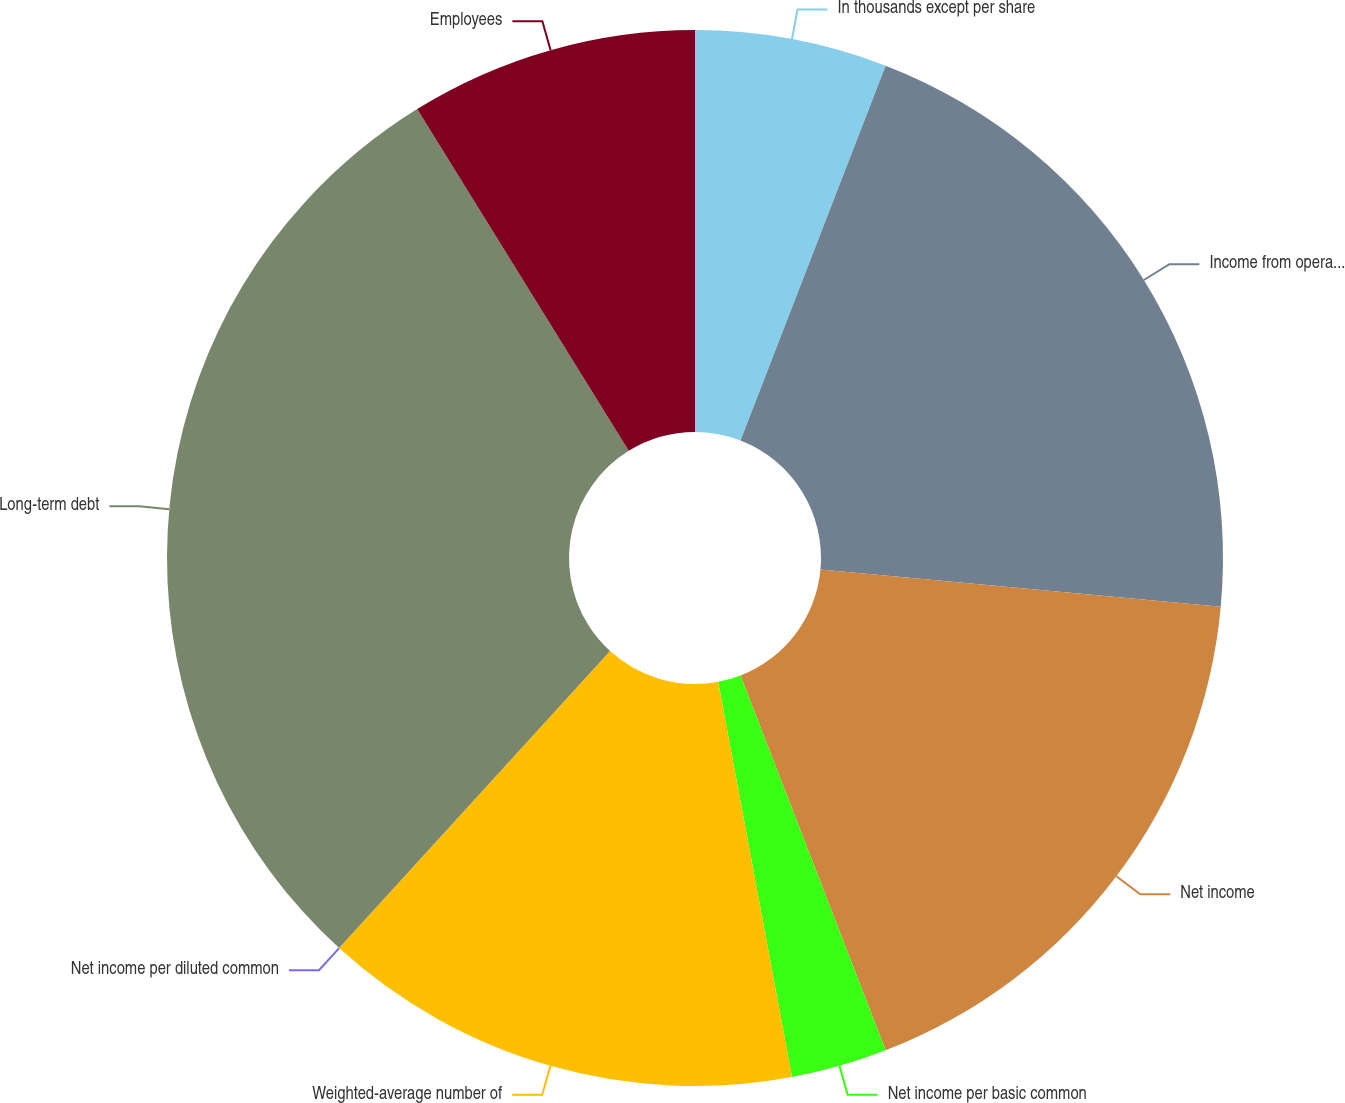<chart> <loc_0><loc_0><loc_500><loc_500><pie_chart><fcel>In thousands except per share<fcel>Income from operations before<fcel>Net income<fcel>Net income per basic common<fcel>Weighted-average number of<fcel>Net income per diluted common<fcel>Long-term debt<fcel>Employees<nl><fcel>5.88%<fcel>20.59%<fcel>17.65%<fcel>2.94%<fcel>14.71%<fcel>0.0%<fcel>29.41%<fcel>8.82%<nl></chart> 